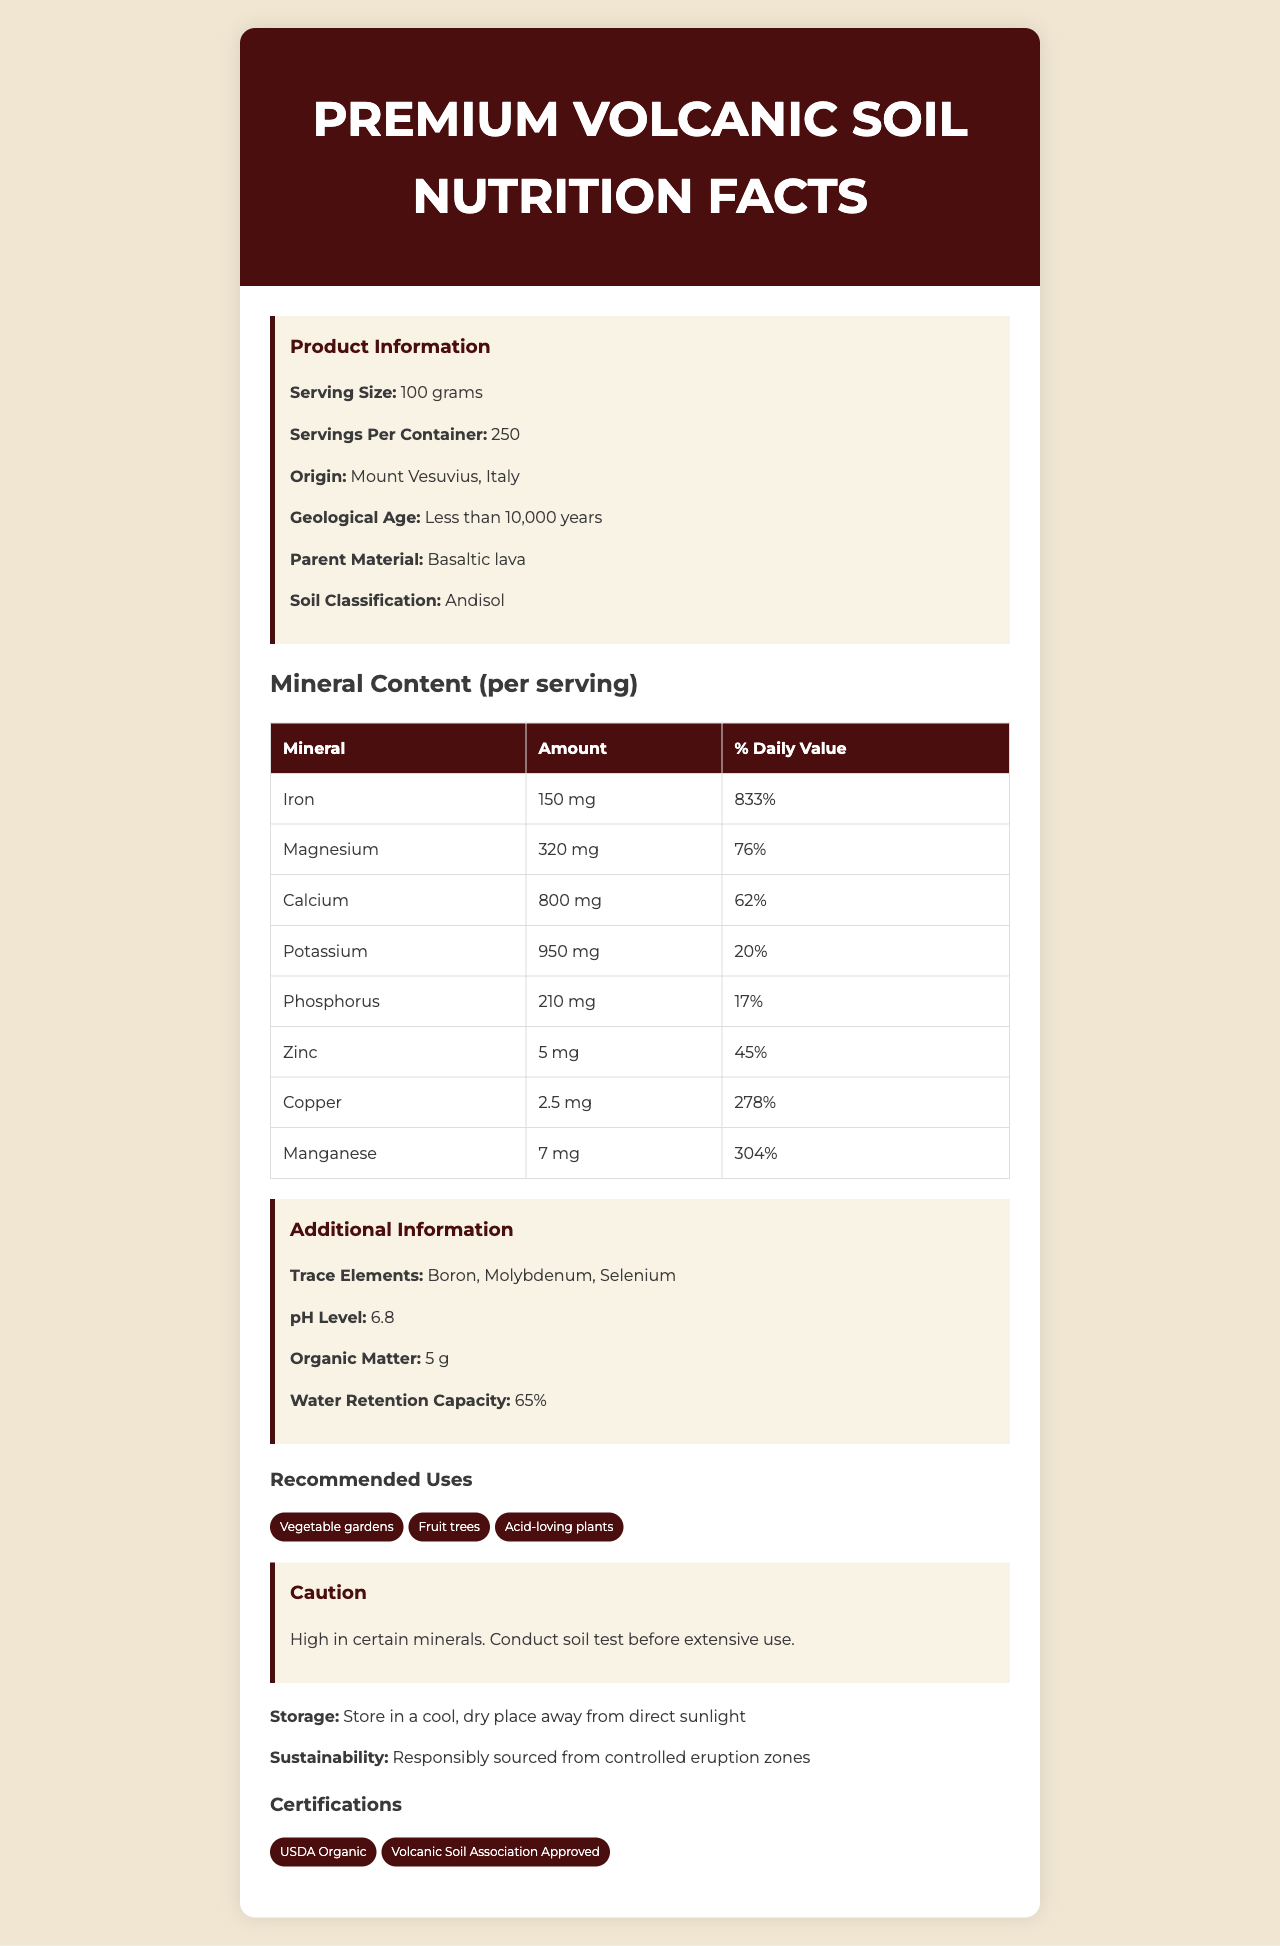what is the serving size for Premium Volcanic Soil? The serving size is explicitly listed as "100 grams" in the product information section.
Answer: 100 grams how much Zinc is there per serving? From the mineral content table, Zinc is listed as 5 mg per serving.
Answer: 5 mg what is the origin of this volcanic soil? In the product information, the origin is stated as Mount Vesuvius, Italy.
Answer: Mount Vesuvius, Italy what is the daily value percentage of Iron? In the table under Mineral Content, Iron is shown to have 833% of the daily value.
Answer: 833% what is the pH level of the Premium Volcanic Soil? The pH level is listed in the Additional Information section as 6.8.
Answer: 6.8 which mineral has the highest daily value percentage? A. Zinc B. Iron C. Copper D. Manganese Iron has the highest daily value percentage at 833%.
Answer: B how much water retention capacity does this soil have? A. 50% B. 60% C. 65% D. 70% The water retention capacity is given as 65% in the Additional Information section.
Answer: C is this soil recommended for vegetable gardens? Vegetable gardens are listed under the Recommended Uses section.
Answer: Yes describe the main idea of the document. The document has sections detailing serving size, mineral content per serving, additional information like pH level and organic matter, cautions, storage instructions, sustainability information, and certifications.
Answer: The document provides detailed nutrition facts and additional information for Premium Volcanic Soil, including mineral content, origin, pH level, recommended uses, and certification. how many years old is the geological age of the soil? In the product information section, it specifies the geological age as "Less than 10,000 years."
Answer: Less than 10,000 years what is the caution mentioned regarding the use of this soil? The caution section advises that the soil is high in certain minerals and recommends conducting a soil test before extensive use.
Answer: High in certain minerals. Conduct soil test before extensive use. can this soil be used for acid-loving plants? Acid-loving plants are listed under the recommended uses section.
Answer: Yes what certifications does this soil have? The certifications are listed at the bottom of the document.
Answer: USDA Organic, Volcanic Soil Association Approved where should the soil be stored? The storage instructions state to store the soil in a cool, dry place away from direct sunlight.
Answer: Store in a cool, dry place away from direct sunlight does the soil contain Boron as a trace element? Boron is listed as one of the trace elements in the Additional Information section.
Answer: Yes what is the amount of organic matter in the soil per serving? The organic matter amount is listed as 5 grams in the Additional Information section.
Answer: 5 grams what are the sustainability practices followed for this soil? The sustainability information states that the soil is responsibly sourced from controlled eruption zones.
Answer: Responsibly sourced from controlled eruption zones which mineral has the lowest daily value percentage? A. Potassium B. Calcium C. Phosphorus D. Copper Phosphorus has the lowest daily value percentage at 17%.
Answer: C how many minerals are listed in the mineral content section? There are eight minerals listed: Iron, Magnesium, Calcium, Potassium, Phosphorus, Zinc, Copper, and Manganese.
Answer: Eight how does volcanic soil contribute to soil fertility? The document does not explicitly explain how volcanic soil contributes to soil fertility.
Answer: Not enough information 